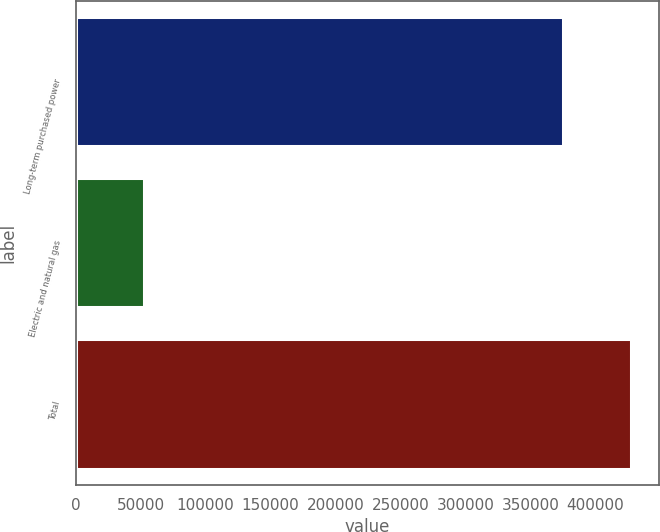Convert chart. <chart><loc_0><loc_0><loc_500><loc_500><bar_chart><fcel>Long-term purchased power<fcel>Electric and natural gas<fcel>Total<nl><fcel>374692<fcel>52968<fcel>427660<nl></chart> 